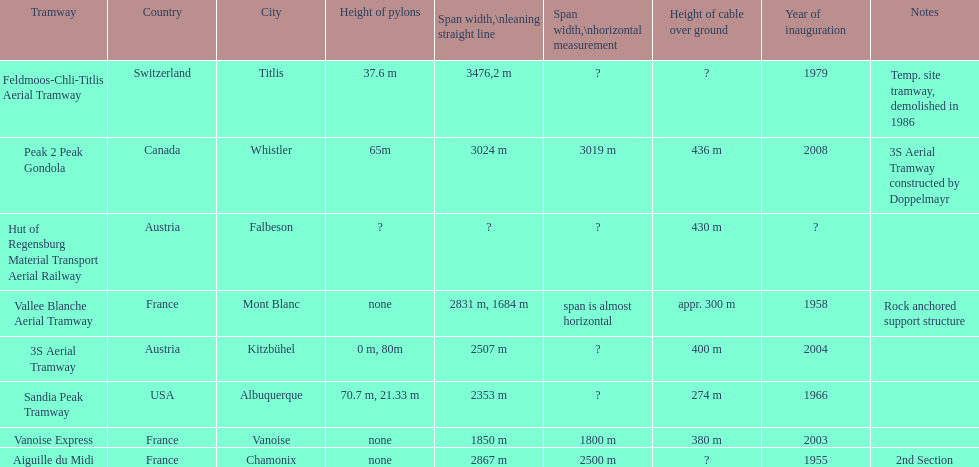Was the sandia peak tramway innagurate before or after the 3s aerial tramway? Before. 